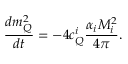<formula> <loc_0><loc_0><loc_500><loc_500>\frac { d m _ { Q } ^ { 2 } } { d t } = - 4 c _ { Q } ^ { i } \frac { \alpha _ { i } M _ { i } ^ { 2 } } { 4 \pi } .</formula> 